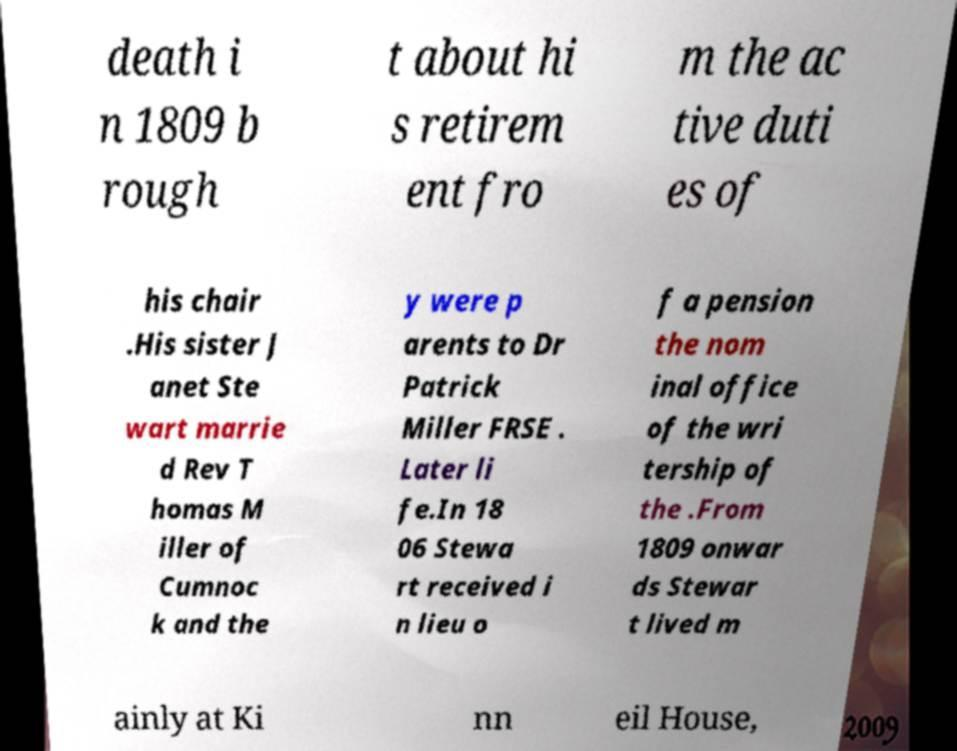I need the written content from this picture converted into text. Can you do that? death i n 1809 b rough t about hi s retirem ent fro m the ac tive duti es of his chair .His sister J anet Ste wart marrie d Rev T homas M iller of Cumnoc k and the y were p arents to Dr Patrick Miller FRSE . Later li fe.In 18 06 Stewa rt received i n lieu o f a pension the nom inal office of the wri tership of the .From 1809 onwar ds Stewar t lived m ainly at Ki nn eil House, 